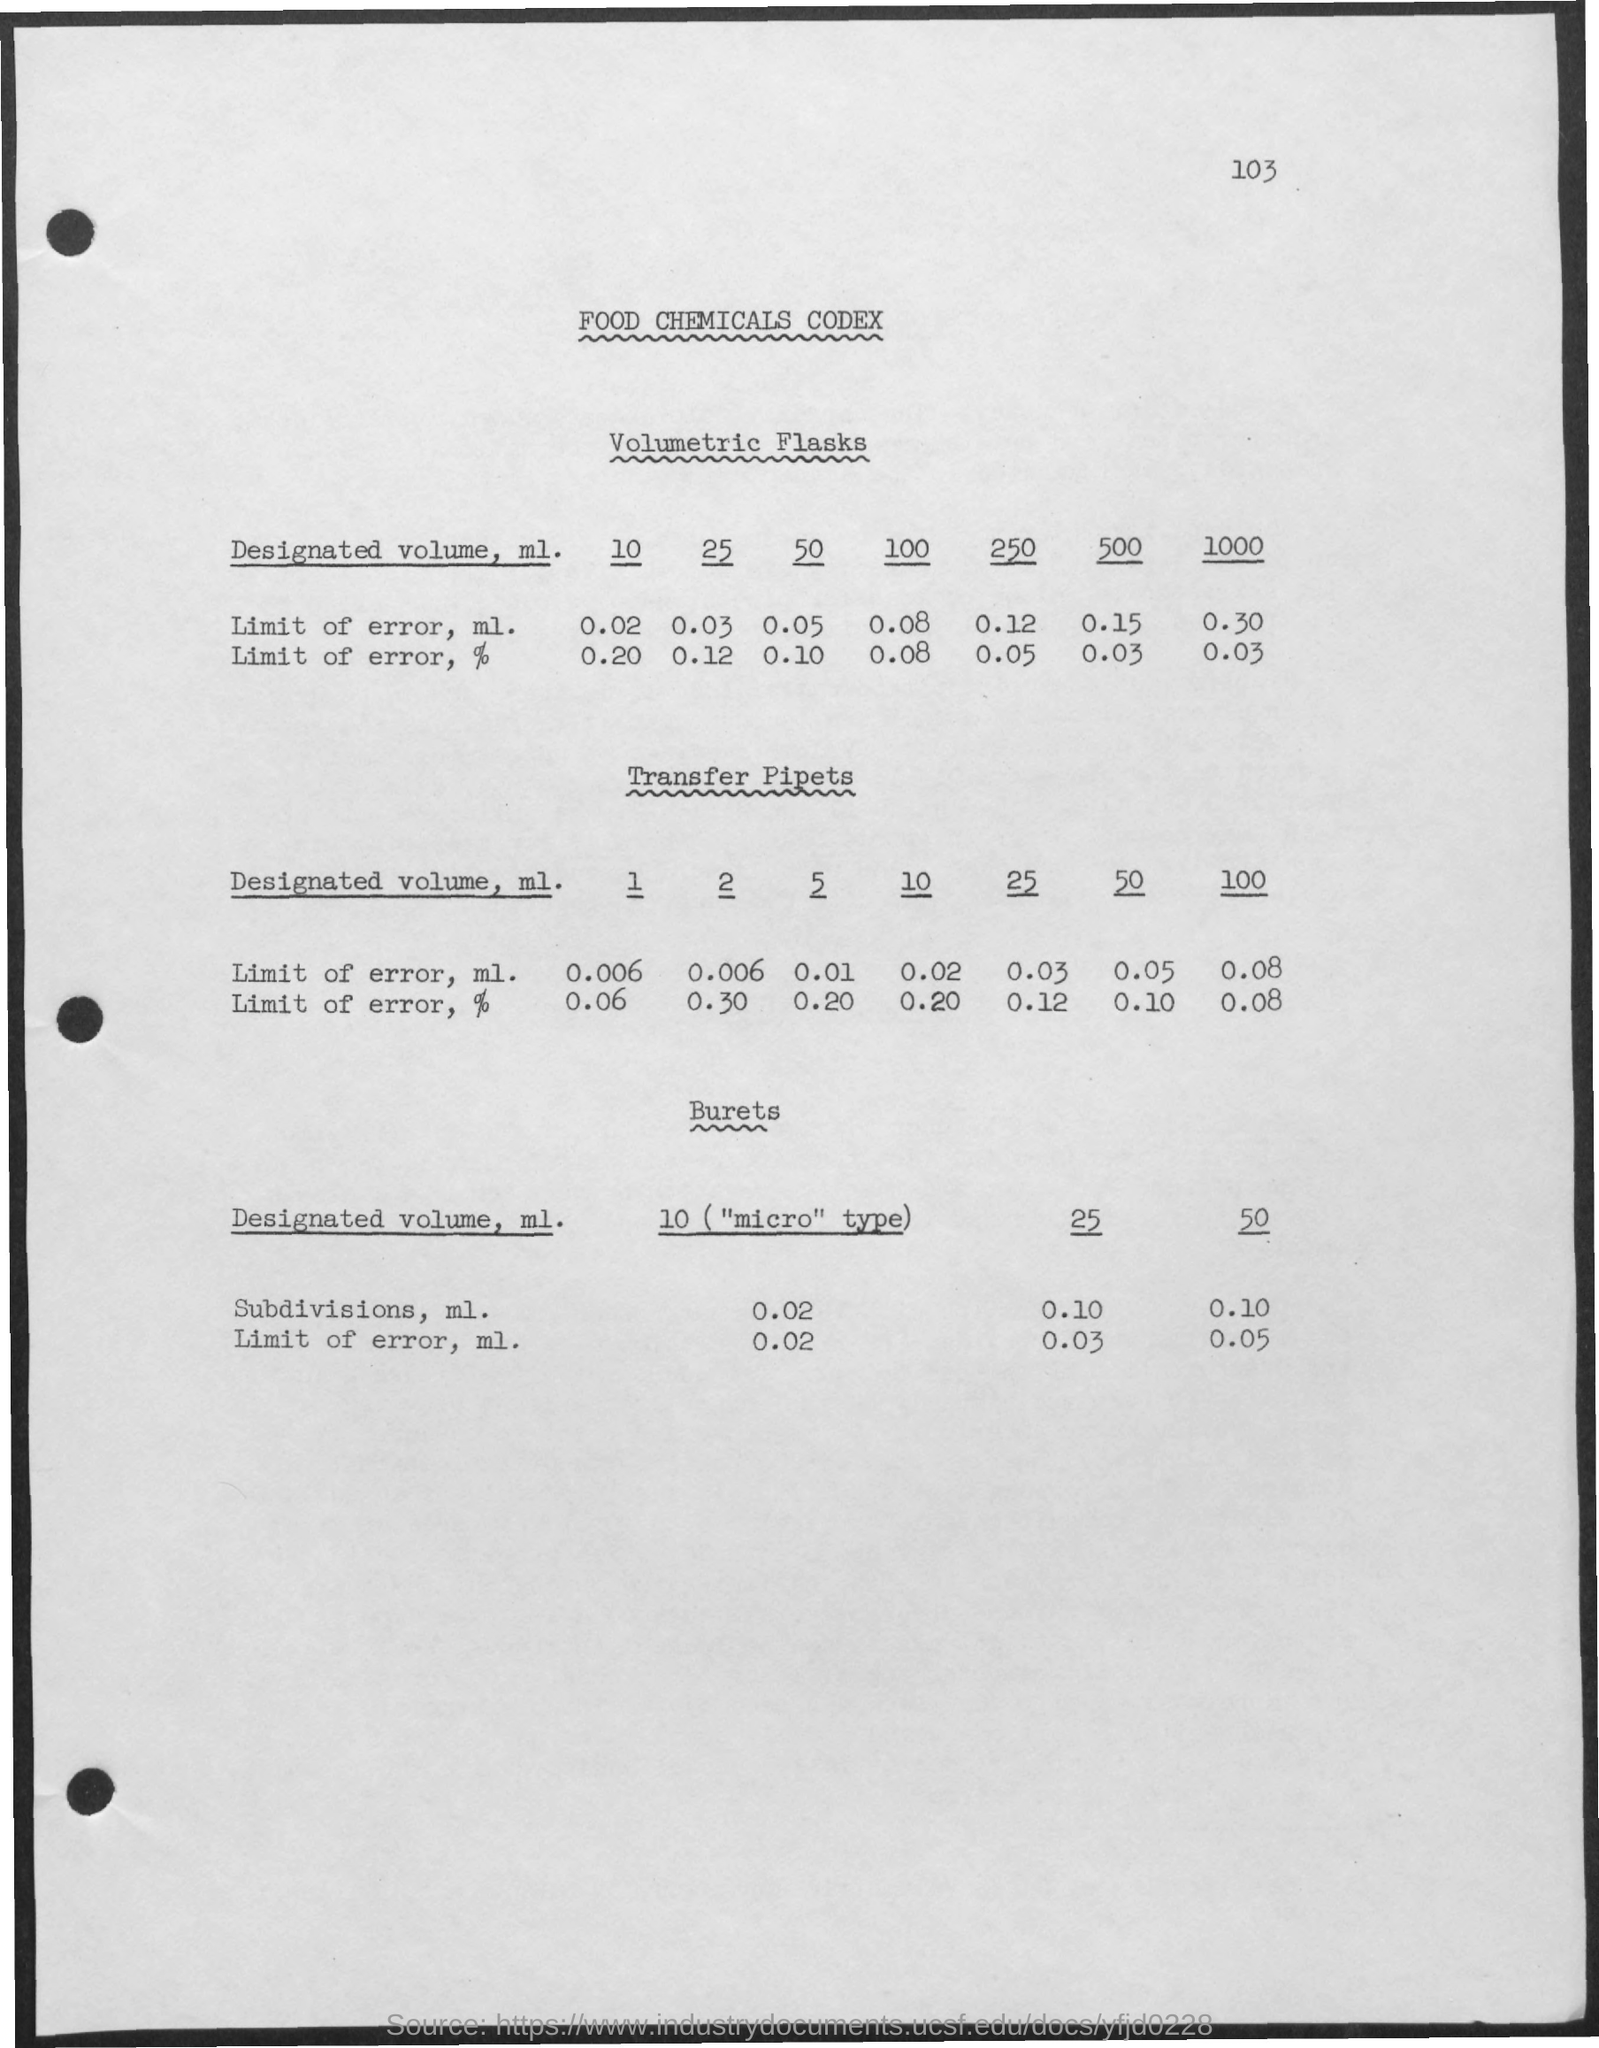Draw attention to some important aspects in this diagram. The page number at the top of the page is 103. The heading of the document is 'Food Chemicals Codex.' 